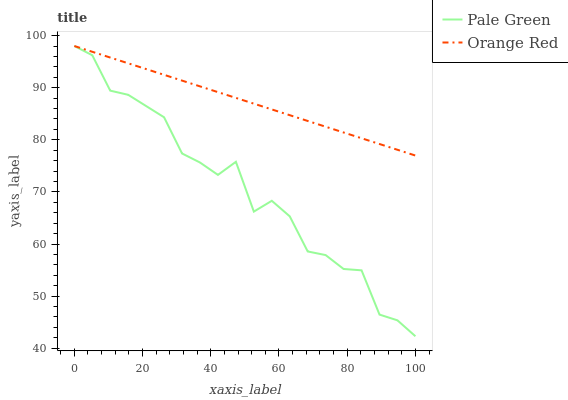Does Pale Green have the minimum area under the curve?
Answer yes or no. Yes. Does Orange Red have the maximum area under the curve?
Answer yes or no. Yes. Does Orange Red have the minimum area under the curve?
Answer yes or no. No. Is Orange Red the smoothest?
Answer yes or no. Yes. Is Pale Green the roughest?
Answer yes or no. Yes. Is Orange Red the roughest?
Answer yes or no. No. Does Pale Green have the lowest value?
Answer yes or no. Yes. Does Orange Red have the lowest value?
Answer yes or no. No. Does Orange Red have the highest value?
Answer yes or no. Yes. Does Orange Red intersect Pale Green?
Answer yes or no. Yes. Is Orange Red less than Pale Green?
Answer yes or no. No. Is Orange Red greater than Pale Green?
Answer yes or no. No. 